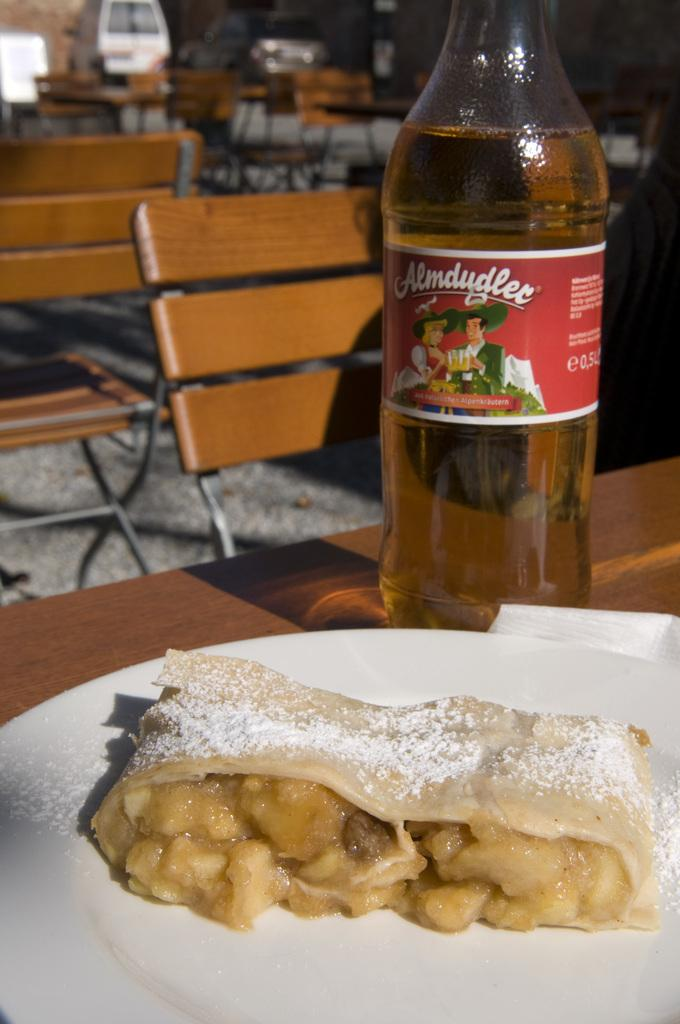What piece of furniture is present in the image? There is a table in the image. What is placed on the table? There is a plate on the table. What can be found on the plate? There are food items on the plate. What type of container is visible in the image? There is a bottle in the image. What might someone use to sit at the table? There is a chair in front of the table. What type of bean is growing on the table in the image? There is no bean present in the image; the table has a plate with food items on it. 